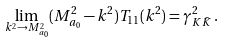<formula> <loc_0><loc_0><loc_500><loc_500>\lim _ { k ^ { 2 } \to M _ { a _ { 0 } } ^ { 2 } } ( M _ { a _ { 0 } } ^ { 2 } - k ^ { 2 } ) T _ { 1 1 } ( k ^ { 2 } ) = \gamma _ { K \bar { K } } ^ { 2 } \, .</formula> 